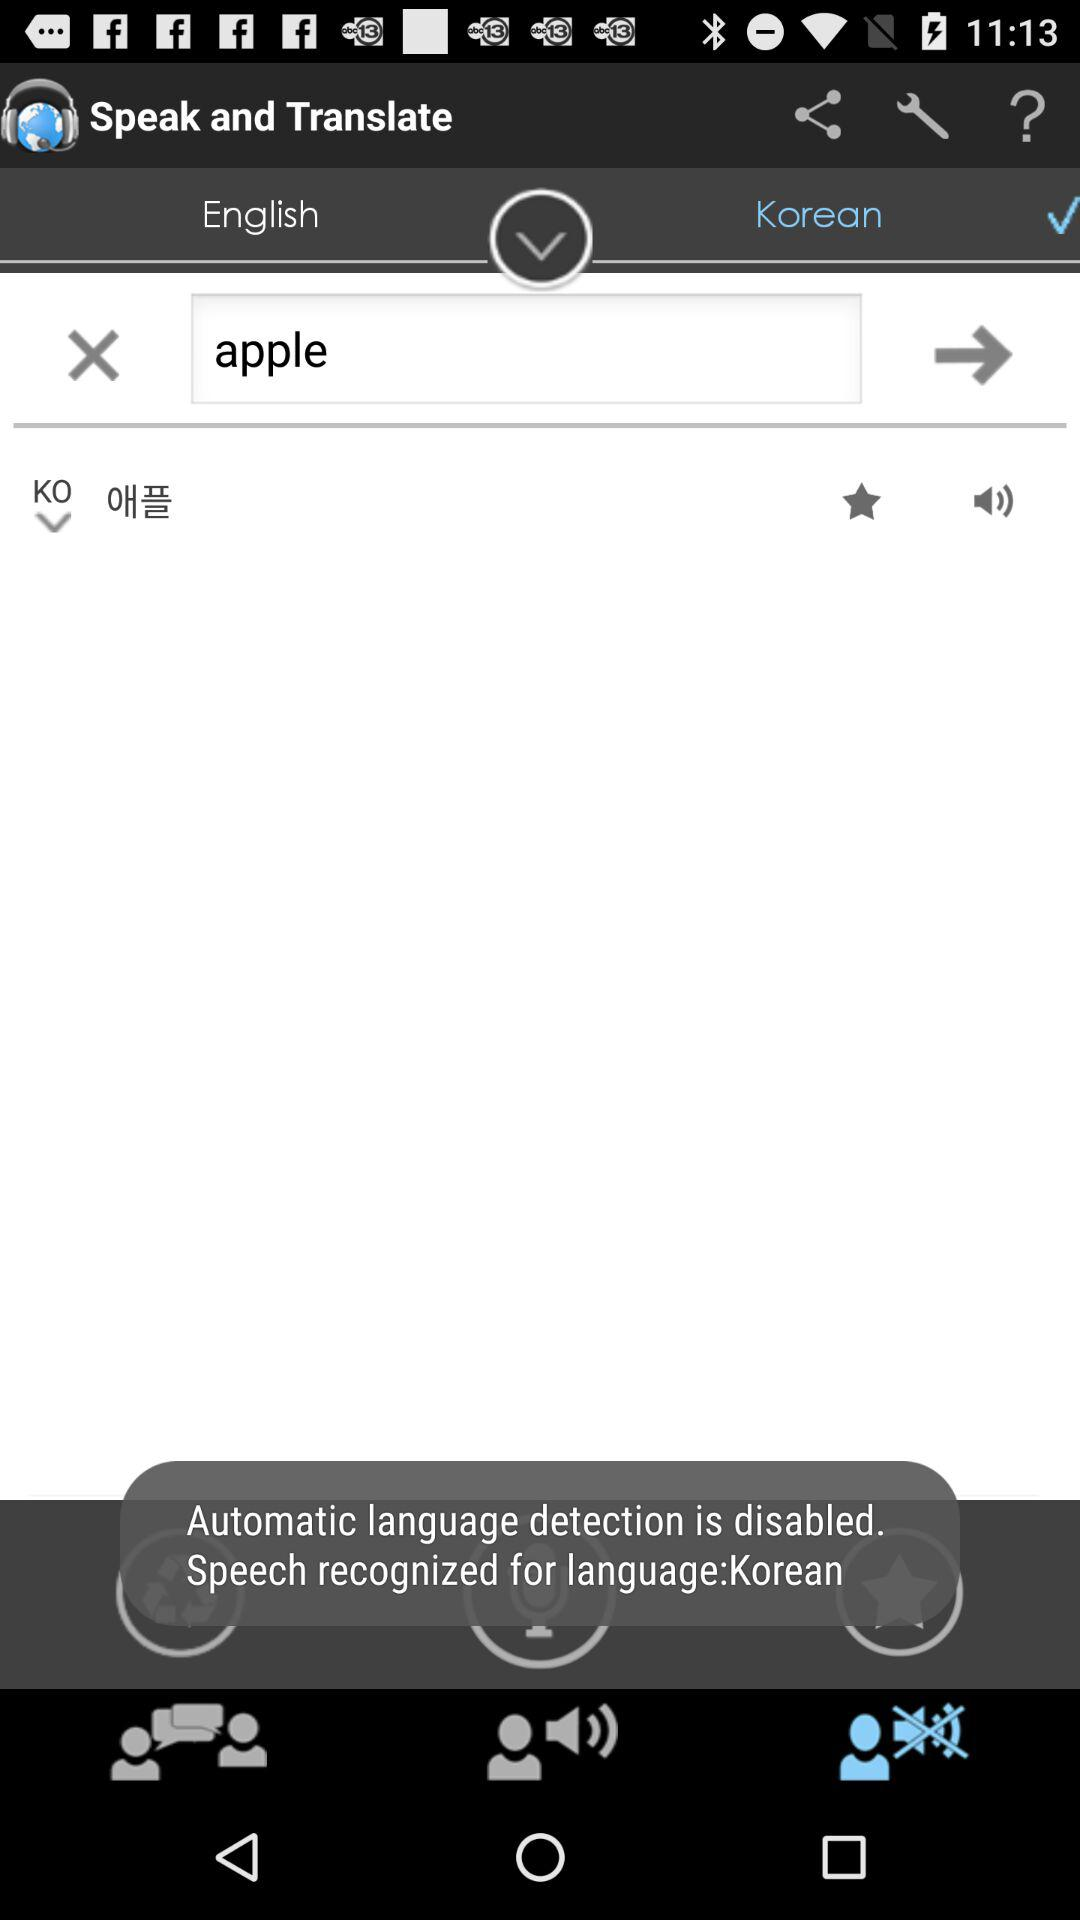To which language is the English language translated? The English language is translated into Korean language. 